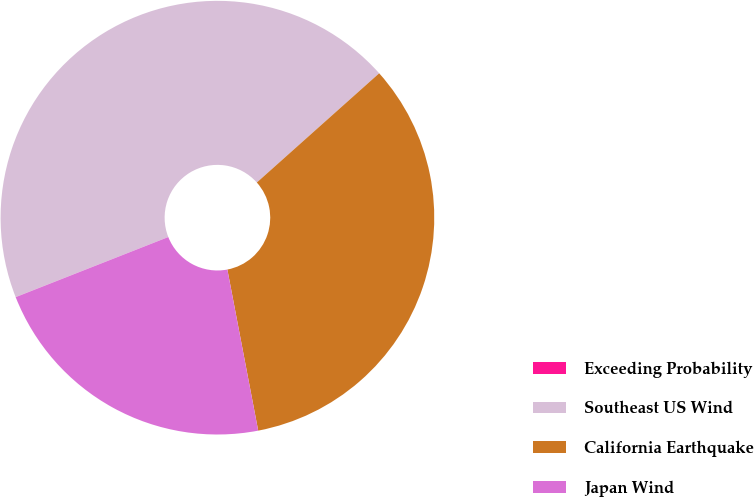Convert chart. <chart><loc_0><loc_0><loc_500><loc_500><pie_chart><fcel>Exceeding Probability<fcel>Southeast US Wind<fcel>California Earthquake<fcel>Japan Wind<nl><fcel>0.01%<fcel>44.37%<fcel>33.59%<fcel>22.04%<nl></chart> 